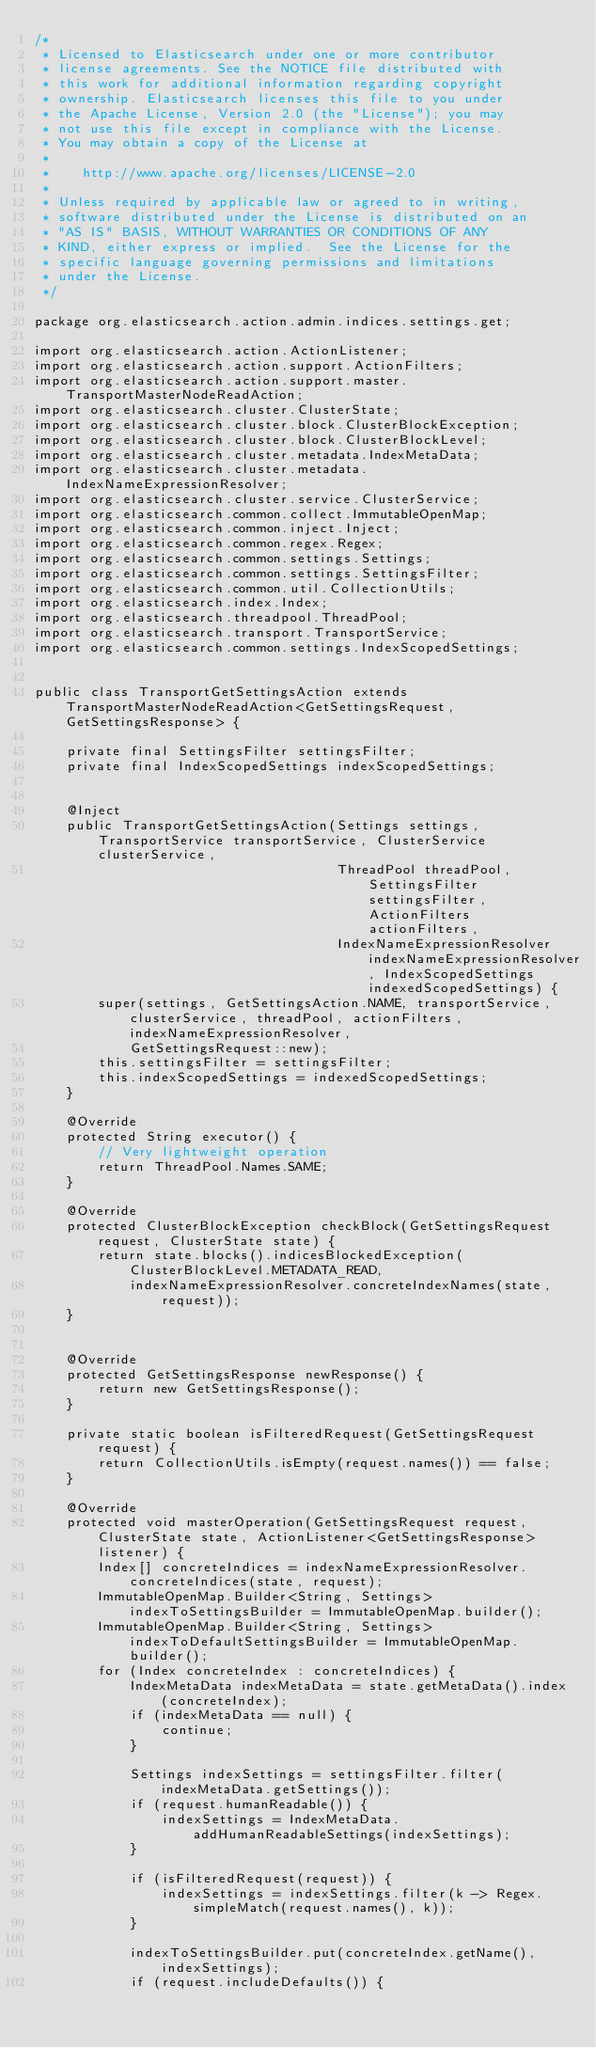Convert code to text. <code><loc_0><loc_0><loc_500><loc_500><_Java_>/*
 * Licensed to Elasticsearch under one or more contributor
 * license agreements. See the NOTICE file distributed with
 * this work for additional information regarding copyright
 * ownership. Elasticsearch licenses this file to you under
 * the Apache License, Version 2.0 (the "License"); you may
 * not use this file except in compliance with the License.
 * You may obtain a copy of the License at
 *
 *    http://www.apache.org/licenses/LICENSE-2.0
 *
 * Unless required by applicable law or agreed to in writing,
 * software distributed under the License is distributed on an
 * "AS IS" BASIS, WITHOUT WARRANTIES OR CONDITIONS OF ANY
 * KIND, either express or implied.  See the License for the
 * specific language governing permissions and limitations
 * under the License.
 */

package org.elasticsearch.action.admin.indices.settings.get;

import org.elasticsearch.action.ActionListener;
import org.elasticsearch.action.support.ActionFilters;
import org.elasticsearch.action.support.master.TransportMasterNodeReadAction;
import org.elasticsearch.cluster.ClusterState;
import org.elasticsearch.cluster.block.ClusterBlockException;
import org.elasticsearch.cluster.block.ClusterBlockLevel;
import org.elasticsearch.cluster.metadata.IndexMetaData;
import org.elasticsearch.cluster.metadata.IndexNameExpressionResolver;
import org.elasticsearch.cluster.service.ClusterService;
import org.elasticsearch.common.collect.ImmutableOpenMap;
import org.elasticsearch.common.inject.Inject;
import org.elasticsearch.common.regex.Regex;
import org.elasticsearch.common.settings.Settings;
import org.elasticsearch.common.settings.SettingsFilter;
import org.elasticsearch.common.util.CollectionUtils;
import org.elasticsearch.index.Index;
import org.elasticsearch.threadpool.ThreadPool;
import org.elasticsearch.transport.TransportService;
import org.elasticsearch.common.settings.IndexScopedSettings;


public class TransportGetSettingsAction extends TransportMasterNodeReadAction<GetSettingsRequest, GetSettingsResponse> {

    private final SettingsFilter settingsFilter;
    private final IndexScopedSettings indexScopedSettings;


    @Inject
    public TransportGetSettingsAction(Settings settings, TransportService transportService, ClusterService clusterService,
                                      ThreadPool threadPool, SettingsFilter settingsFilter, ActionFilters actionFilters,
                                      IndexNameExpressionResolver indexNameExpressionResolver, IndexScopedSettings indexedScopedSettings) {
        super(settings, GetSettingsAction.NAME, transportService, clusterService, threadPool, actionFilters, indexNameExpressionResolver,
            GetSettingsRequest::new);
        this.settingsFilter = settingsFilter;
        this.indexScopedSettings = indexedScopedSettings;
    }

    @Override
    protected String executor() {
        // Very lightweight operation
        return ThreadPool.Names.SAME;
    }

    @Override
    protected ClusterBlockException checkBlock(GetSettingsRequest request, ClusterState state) {
        return state.blocks().indicesBlockedException(ClusterBlockLevel.METADATA_READ,
            indexNameExpressionResolver.concreteIndexNames(state, request));
    }


    @Override
    protected GetSettingsResponse newResponse() {
        return new GetSettingsResponse();
    }

    private static boolean isFilteredRequest(GetSettingsRequest request) {
        return CollectionUtils.isEmpty(request.names()) == false;
    }

    @Override
    protected void masterOperation(GetSettingsRequest request, ClusterState state, ActionListener<GetSettingsResponse> listener) {
        Index[] concreteIndices = indexNameExpressionResolver.concreteIndices(state, request);
        ImmutableOpenMap.Builder<String, Settings> indexToSettingsBuilder = ImmutableOpenMap.builder();
        ImmutableOpenMap.Builder<String, Settings> indexToDefaultSettingsBuilder = ImmutableOpenMap.builder();
        for (Index concreteIndex : concreteIndices) {
            IndexMetaData indexMetaData = state.getMetaData().index(concreteIndex);
            if (indexMetaData == null) {
                continue;
            }

            Settings indexSettings = settingsFilter.filter(indexMetaData.getSettings());
            if (request.humanReadable()) {
                indexSettings = IndexMetaData.addHumanReadableSettings(indexSettings);
            }

            if (isFilteredRequest(request)) {
                indexSettings = indexSettings.filter(k -> Regex.simpleMatch(request.names(), k));
            }

            indexToSettingsBuilder.put(concreteIndex.getName(), indexSettings);
            if (request.includeDefaults()) {</code> 